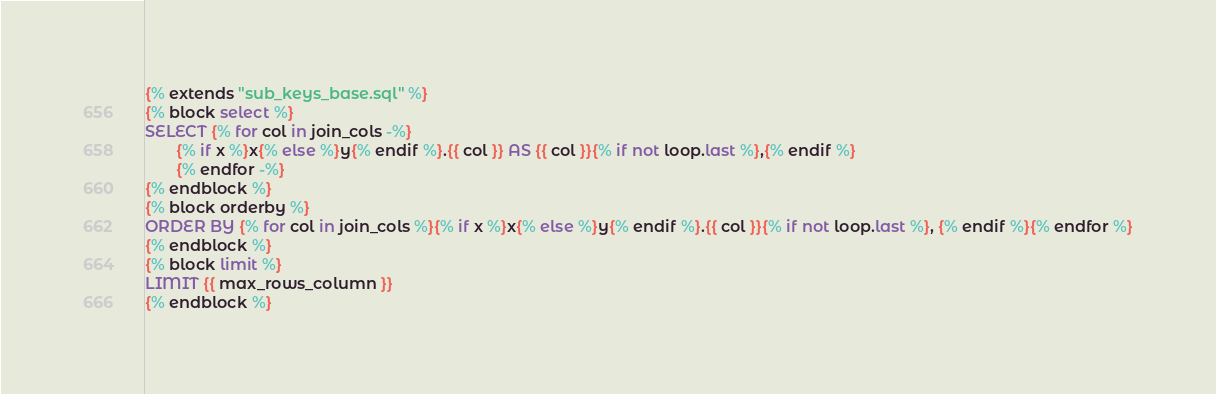<code> <loc_0><loc_0><loc_500><loc_500><_SQL_>{% extends "sub_keys_base.sql" %}
{% block select %}
SELECT {% for col in join_cols -%}
       {% if x %}x{% else %}y{% endif %}.{{ col }} AS {{ col }}{% if not loop.last %},{% endif %}
       {% endfor -%}
{% endblock %}
{% block orderby %}
ORDER BY {% for col in join_cols %}{% if x %}x{% else %}y{% endif %}.{{ col }}{% if not loop.last %}, {% endif %}{% endfor %}
{% endblock %}
{% block limit %}
LIMIT {{ max_rows_column }}
{% endblock %}

</code> 